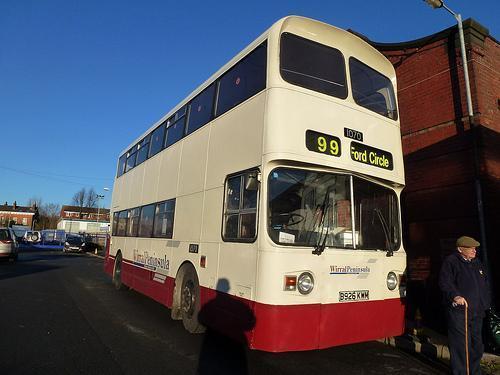How many stories does the bus have?
Give a very brief answer. 2. How many people are in the picture?
Give a very brief answer. 1. How many people are in front of the bus?
Give a very brief answer. 1. How many vehicles are there?
Give a very brief answer. 4. 